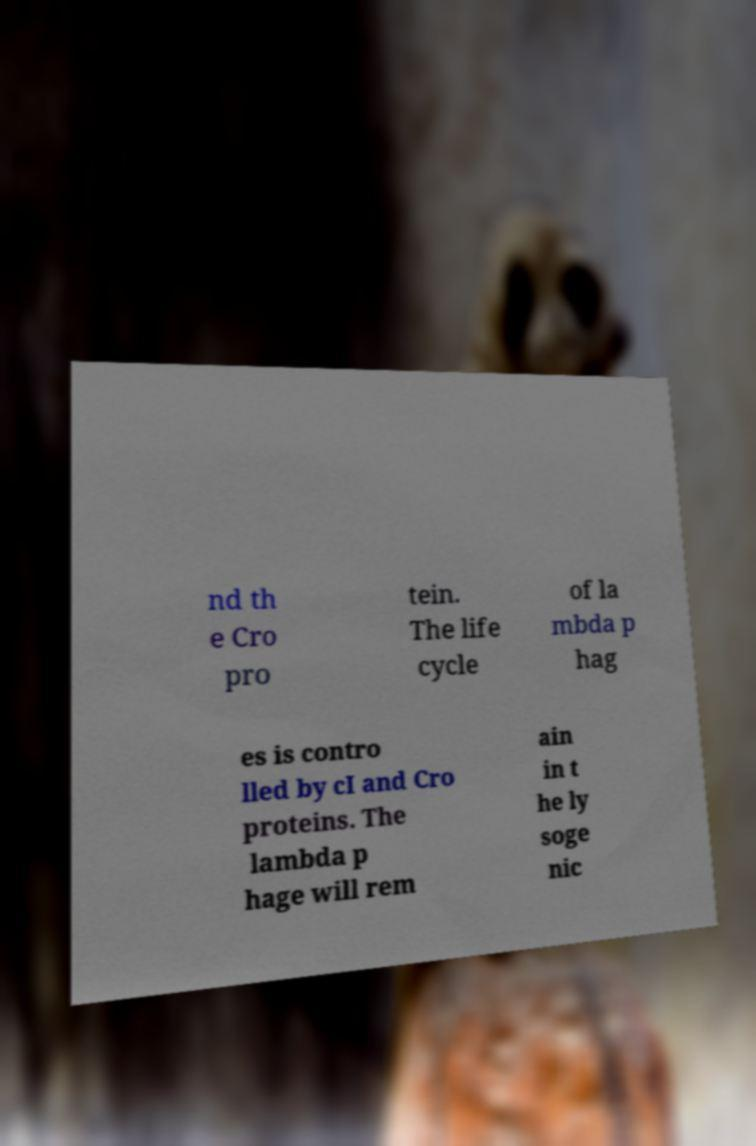Can you read and provide the text displayed in the image?This photo seems to have some interesting text. Can you extract and type it out for me? nd th e Cro pro tein. The life cycle of la mbda p hag es is contro lled by cI and Cro proteins. The lambda p hage will rem ain in t he ly soge nic 